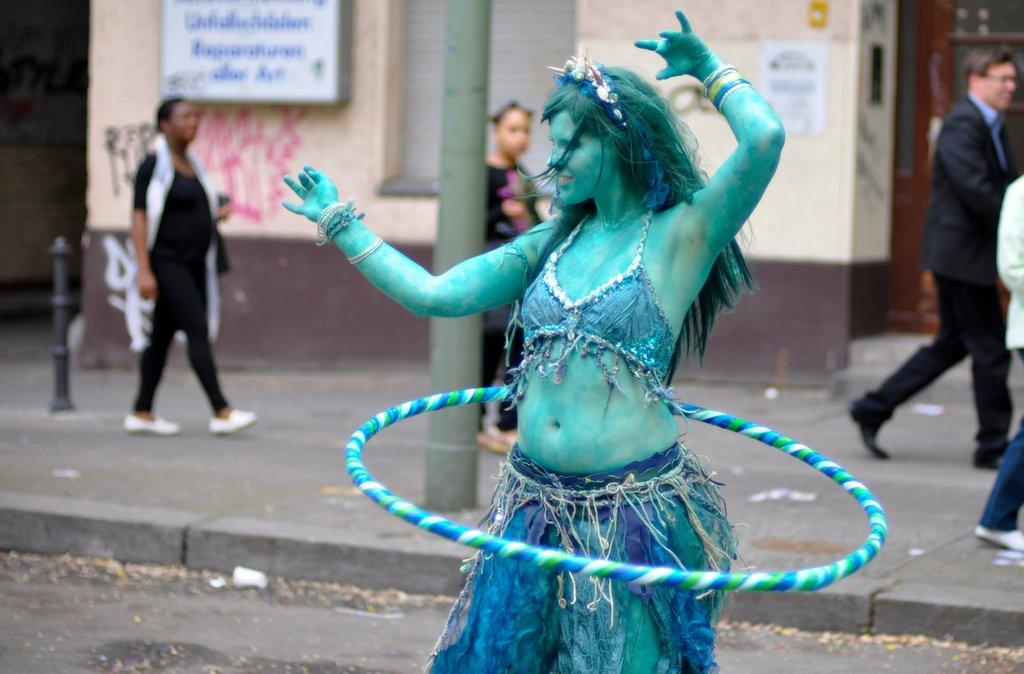What is the primary subject of the image? There is a woman standing in the image. What is the woman's position relative to the ground? The woman is standing on the ground. Can you describe the background of the image? There are persons visible in the background of the image, and there is a wall in the background as well. What type of square object can be seen in the woman's hand in the image? There is no square object visible in the woman's hand in the image. What kind of ray is emitted from the woman's forehead in the image? There is no ray emitted from the woman's forehead in the image. 